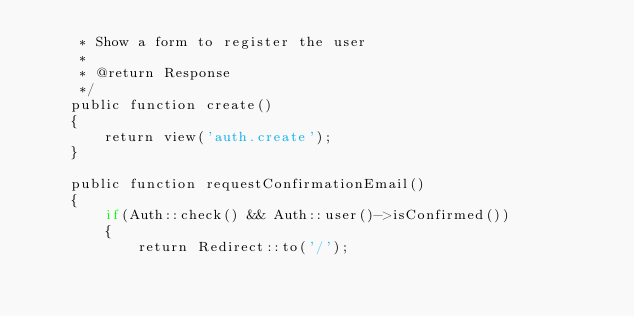Convert code to text. <code><loc_0><loc_0><loc_500><loc_500><_PHP_>	 * Show a form to register the user
	 *
	 * @return Response
	 */
	public function create()
	{		
		return view('auth.create');
	}
	
	public function requestConfirmationEmail()
	{
		if(Auth::check() && Auth::user()->isConfirmed())
		{
			return Redirect::to('/');</code> 